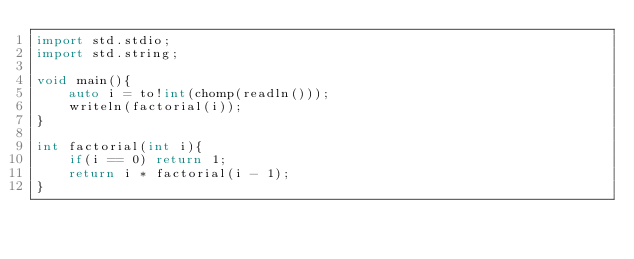<code> <loc_0><loc_0><loc_500><loc_500><_D_>import std.stdio;
import std.string;

void main(){
    auto i = to!int(chomp(readln()));
    writeln(factorial(i));
}

int factorial(int i){
    if(i == 0) return 1;
    return i * factorial(i - 1);
}</code> 